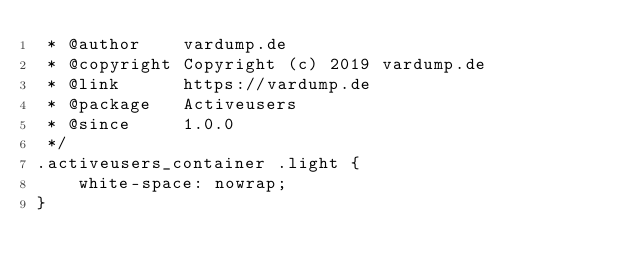<code> <loc_0><loc_0><loc_500><loc_500><_CSS_> * @author    vardump.de
 * @copyright Copyright (c) 2019 vardump.de
 * @link      https://vardump.de
 * @package   Activeusers
 * @since     1.0.0
 */
.activeusers_container .light {
    white-space: nowrap;
}</code> 